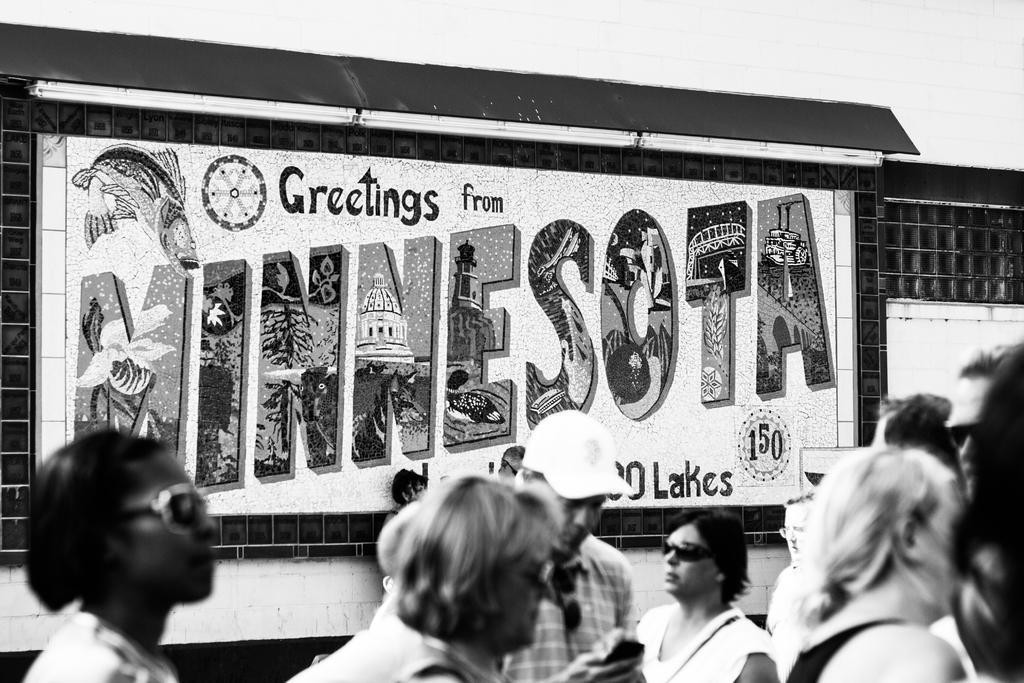Can you describe this image briefly? In this image I can see few people standing. Back I can see a board and something is written on it. The image is in black and white. 